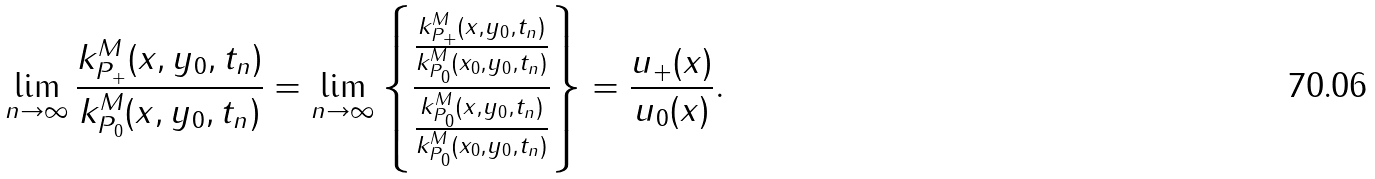<formula> <loc_0><loc_0><loc_500><loc_500>\lim _ { n \to \infty } \frac { k _ { P _ { + } } ^ { M } ( x , y _ { 0 } , t _ { n } ) } { k _ { P _ { 0 } } ^ { M } ( x , y _ { 0 } , t _ { n } ) } = \lim _ { n \to \infty } \left \{ \frac { \frac { k _ { P _ { + } } ^ { M } ( x , y _ { 0 } , t _ { n } ) } { k _ { P _ { 0 } } ^ { M } ( x _ { 0 } , y _ { 0 } , t _ { n } ) } } { \frac { k _ { P _ { 0 } } ^ { M } ( x , y _ { 0 } , t _ { n } ) } { k _ { P _ { 0 } } ^ { M } ( x _ { 0 } , y _ { 0 } , t _ { n } ) } } \right \} = \frac { u _ { + } ( x ) } { u _ { 0 } ( x ) } .</formula> 